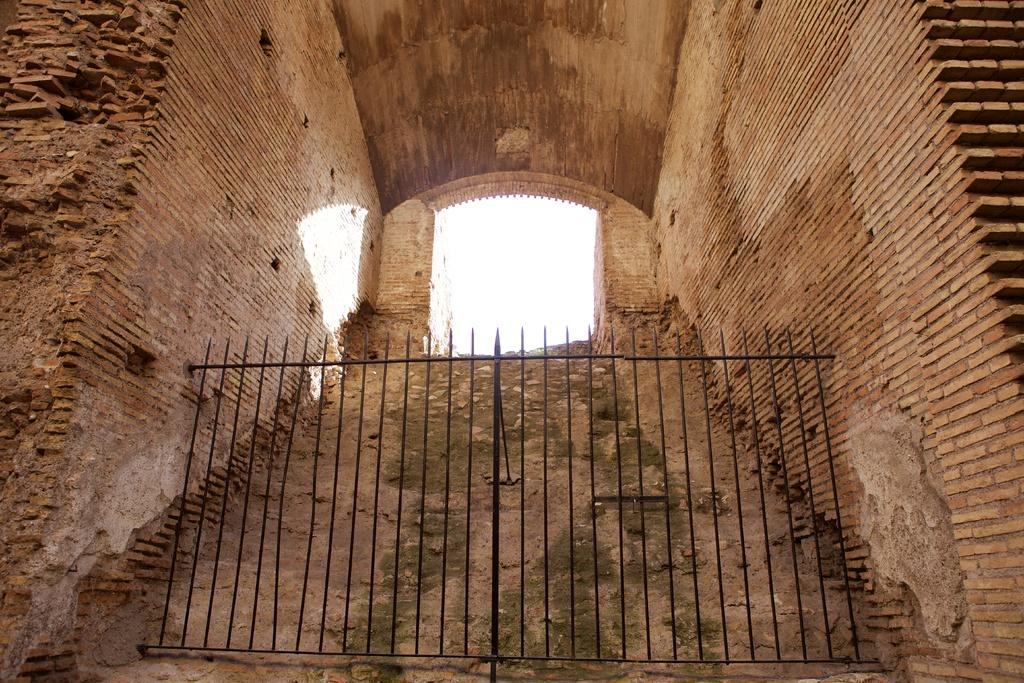What is the main object in the image? There is a grill in the image. What type of material is used for the walls in the image? There are brick walls in the image. What type of music is being played near the grill in the image? There is no information about music being played in the image; it only features a grill and brick walls. 